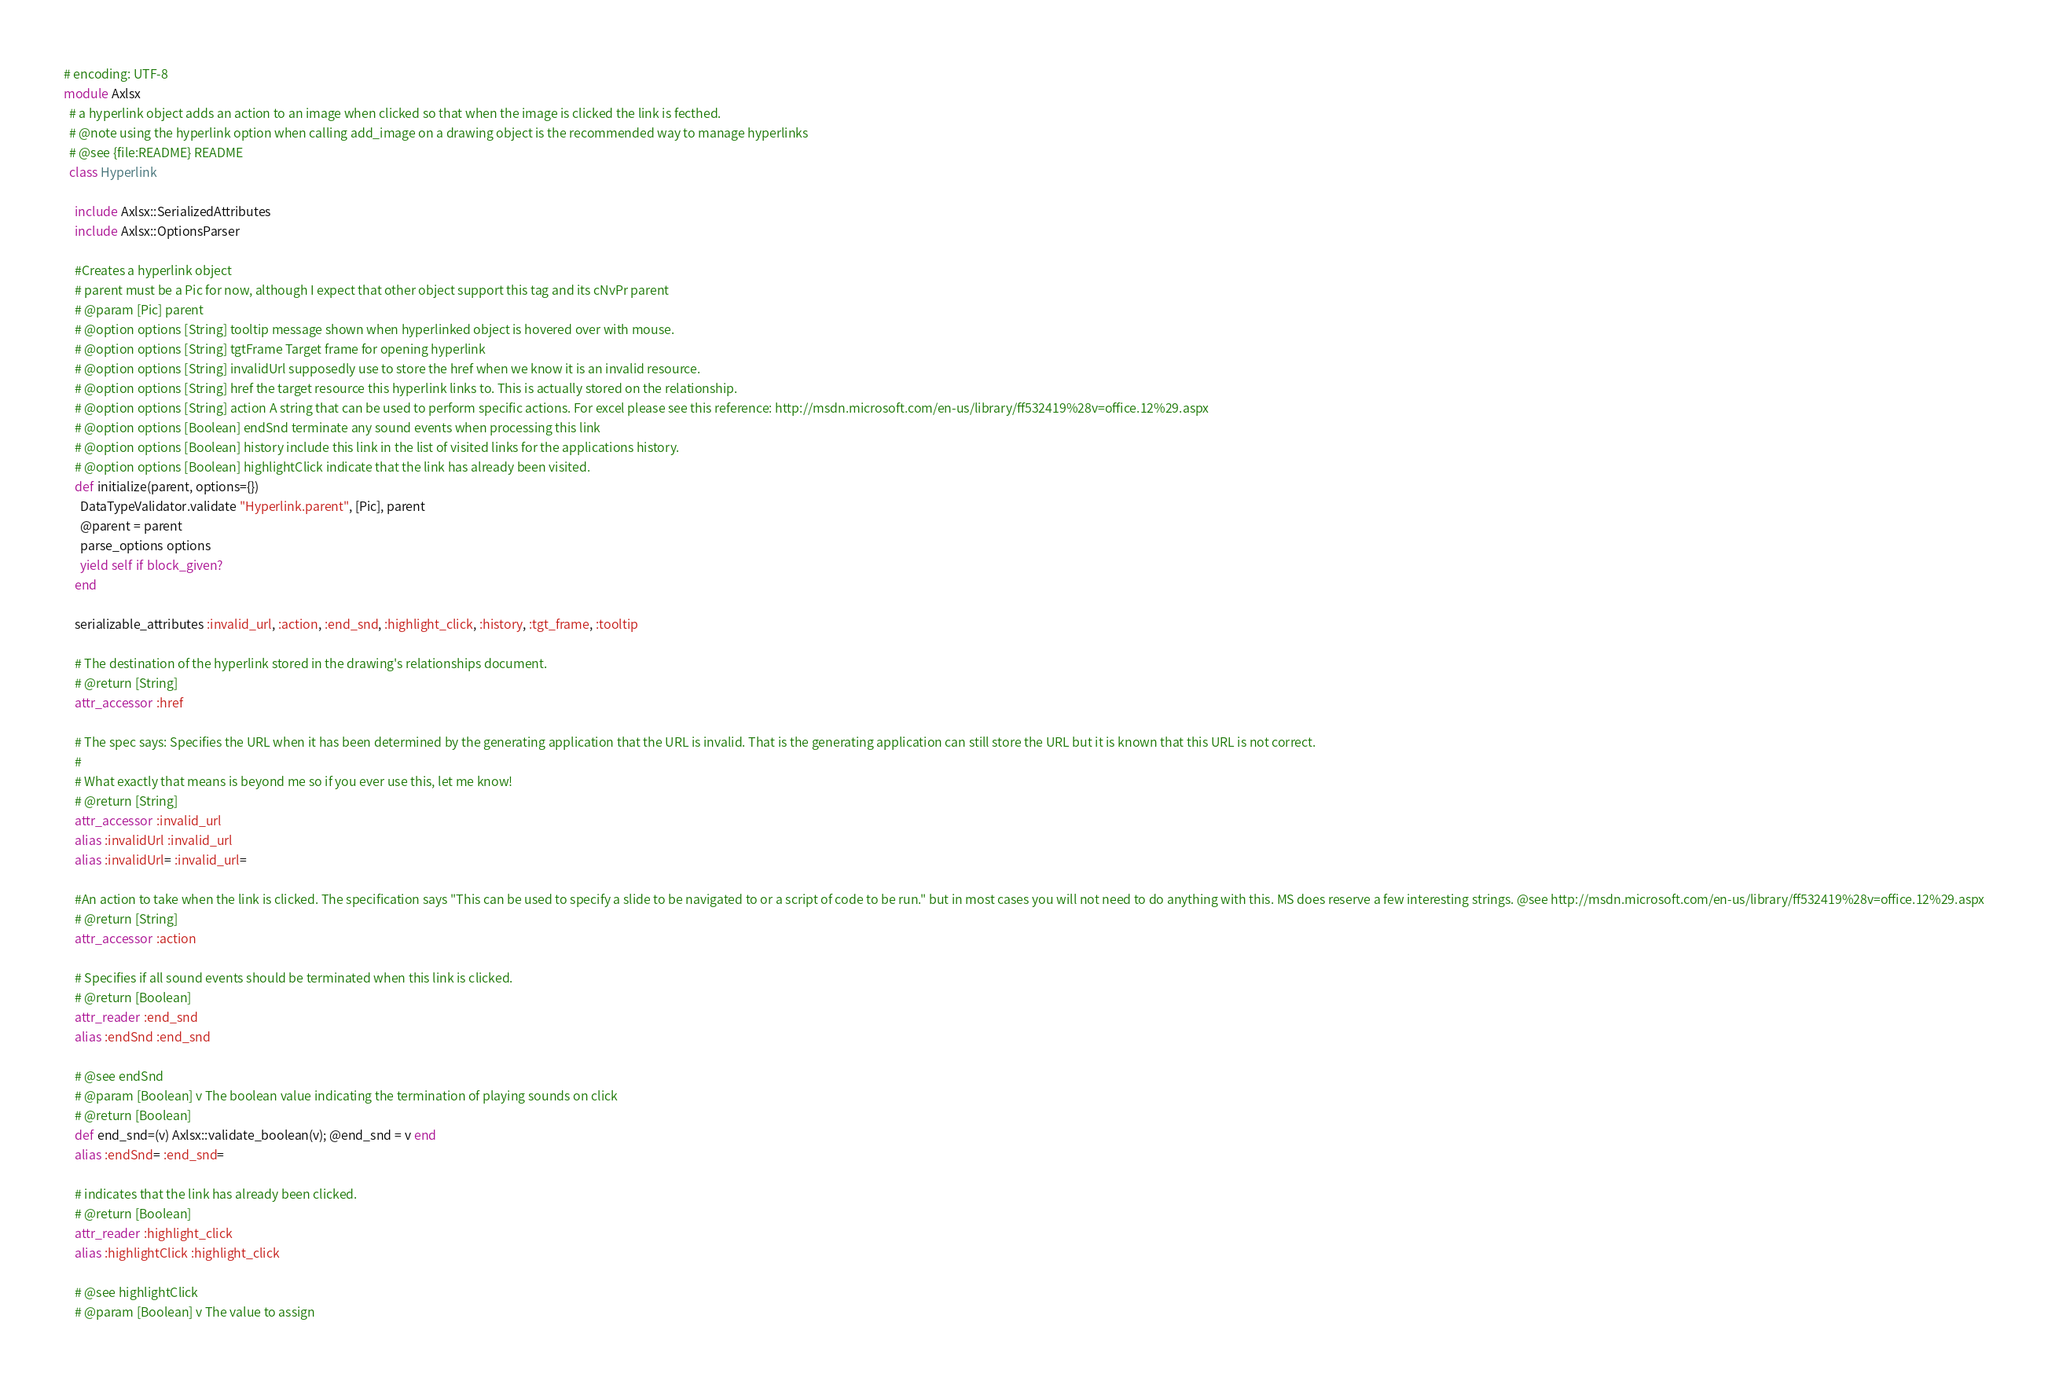Convert code to text. <code><loc_0><loc_0><loc_500><loc_500><_Ruby_># encoding: UTF-8
module Axlsx
  # a hyperlink object adds an action to an image when clicked so that when the image is clicked the link is fecthed.
  # @note using the hyperlink option when calling add_image on a drawing object is the recommended way to manage hyperlinks
  # @see {file:README} README
  class Hyperlink

    include Axlsx::SerializedAttributes
    include Axlsx::OptionsParser

    #Creates a hyperlink object
    # parent must be a Pic for now, although I expect that other object support this tag and its cNvPr parent
    # @param [Pic] parent
    # @option options [String] tooltip message shown when hyperlinked object is hovered over with mouse.
    # @option options [String] tgtFrame Target frame for opening hyperlink
    # @option options [String] invalidUrl supposedly use to store the href when we know it is an invalid resource.
    # @option options [String] href the target resource this hyperlink links to. This is actually stored on the relationship.
    # @option options [String] action A string that can be used to perform specific actions. For excel please see this reference: http://msdn.microsoft.com/en-us/library/ff532419%28v=office.12%29.aspx
    # @option options [Boolean] endSnd terminate any sound events when processing this link
    # @option options [Boolean] history include this link in the list of visited links for the applications history.
    # @option options [Boolean] highlightClick indicate that the link has already been visited.
    def initialize(parent, options={})
      DataTypeValidator.validate "Hyperlink.parent", [Pic], parent
      @parent = parent
      parse_options options
      yield self if block_given?
    end

    serializable_attributes :invalid_url, :action, :end_snd, :highlight_click, :history, :tgt_frame, :tooltip

    # The destination of the hyperlink stored in the drawing's relationships document.
    # @return [String]
    attr_accessor :href

    # The spec says: Specifies the URL when it has been determined by the generating application that the URL is invalid. That is the generating application can still store the URL but it is known that this URL is not correct.
    #
    # What exactly that means is beyond me so if you ever use this, let me know!
    # @return [String]
    attr_accessor :invalid_url
    alias :invalidUrl :invalid_url
    alias :invalidUrl= :invalid_url=

    #An action to take when the link is clicked. The specification says "This can be used to specify a slide to be navigated to or a script of code to be run." but in most cases you will not need to do anything with this. MS does reserve a few interesting strings. @see http://msdn.microsoft.com/en-us/library/ff532419%28v=office.12%29.aspx
    # @return [String]
    attr_accessor :action

    # Specifies if all sound events should be terminated when this link is clicked.
    # @return [Boolean]
    attr_reader :end_snd
    alias :endSnd :end_snd

    # @see endSnd
    # @param [Boolean] v The boolean value indicating the termination of playing sounds on click
    # @return [Boolean]
    def end_snd=(v) Axlsx::validate_boolean(v); @end_snd = v end
    alias :endSnd= :end_snd=

    # indicates that the link has already been clicked.
    # @return [Boolean]
    attr_reader :highlight_click
    alias :highlightClick :highlight_click

    # @see highlightClick
    # @param [Boolean] v The value to assign</code> 